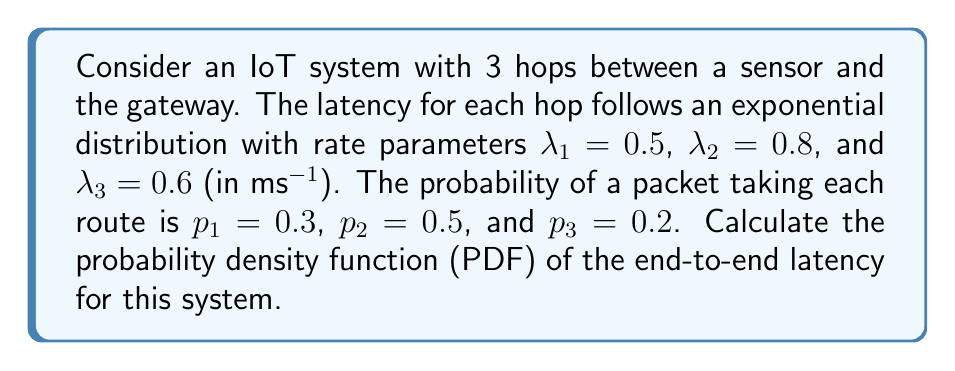Can you solve this math problem? To solve this problem, we'll follow these steps:

1) The latency for each hop follows an exponential distribution. The PDF of an exponential distribution is given by:

   $$f(x) = \lambda e^{-\lambda x}$$

2) The end-to-end latency is the sum of the latencies of all three hops. The sum of independent exponential distributions follows an Erlang distribution.

3) The PDF of an Erlang distribution with shape parameter $k$ and rate parameter $\lambda$ is:

   $$f(x) = \frac{\lambda^k x^{k-1} e^{-\lambda x}}{(k-1)!}$$

4) In our case, we have three different rate parameters. This results in a hypoexponential distribution, which is a generalization of the Erlang distribution.

5) The PDF of a hypoexponential distribution with parameters $\lambda_1, \lambda_2, \lambda_3$ is:

   $$f(x) = \sum_{i=1}^3 A_i \lambda_i e^{-\lambda_i x}$$

   where $A_i = \prod_{j \neq i} \frac{\lambda_j}{\lambda_j - \lambda_i}$

6) Calculating the $A_i$ values:

   $A_1 = \frac{0.8}{0.8-0.5} \cdot \frac{0.6}{0.6-0.5} = 1.6$
   $A_2 = \frac{0.5}{0.5-0.8} \cdot \frac{0.6}{0.6-0.8} = -4$
   $A_3 = \frac{0.5}{0.5-0.6} \cdot \frac{0.8}{0.8-0.6} = 2.4$

7) The PDF for each route is:

   $f_1(x) = 1.6 \cdot 0.5e^{-0.5x} - 4 \cdot 0.8e^{-0.8x} + 2.4 \cdot 0.6e^{-0.6x}$
   $f_2(x) = 1.6 \cdot 0.5e^{-0.5x} - 4 \cdot 0.8e^{-0.8x} + 2.4 \cdot 0.6e^{-0.6x}$
   $f_3(x) = 1.6 \cdot 0.5e^{-0.5x} - 4 \cdot 0.8e^{-0.8x} + 2.4 \cdot 0.6e^{-0.6x}$

8) The final PDF is the weighted sum of these individual PDFs:

   $f(x) = 0.3f_1(x) + 0.5f_2(x) + 0.2f_3(x)$

9) Simplifying:

   $f(x) = (0.3 + 0.5 + 0.2)(1.6 \cdot 0.5e^{-0.5x} - 4 \cdot 0.8e^{-0.8x} + 2.4 \cdot 0.6e^{-0.6x})$
   $f(x) = 0.8e^{-0.5x} - 3.2e^{-0.8x} + 1.44e^{-0.6x}$
Answer: $f(x) = 0.8e^{-0.5x} - 3.2e^{-0.8x} + 1.44e^{-0.6x}$ 